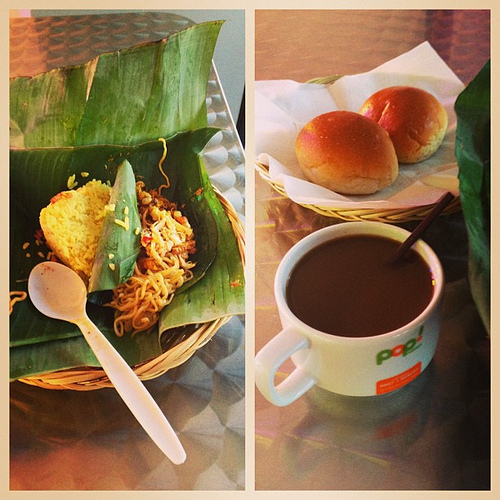What food is to the left of the brown drink? Positioned to the left of the rich brown coffee are the noodles, enticing with their simplicity and promise of hearty warmth. 